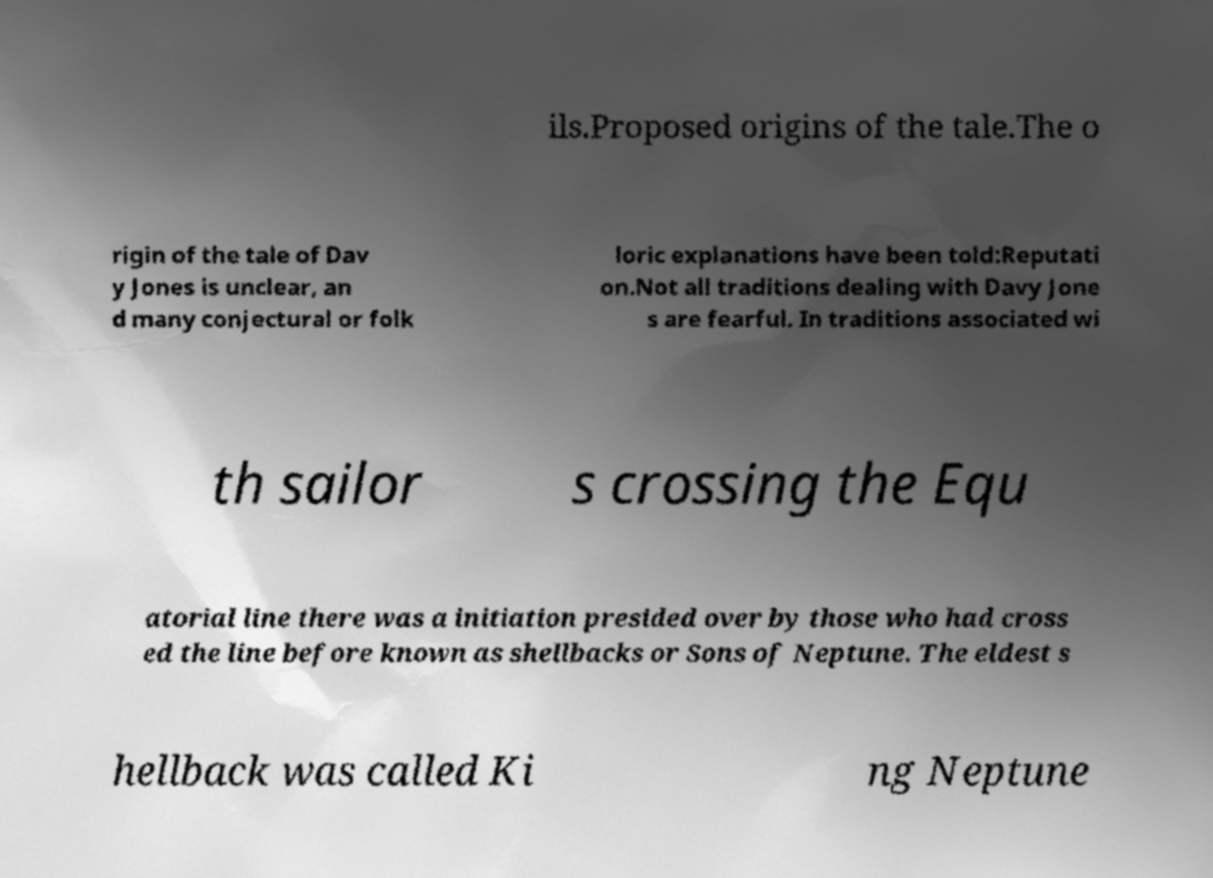Can you accurately transcribe the text from the provided image for me? ils.Proposed origins of the tale.The o rigin of the tale of Dav y Jones is unclear, an d many conjectural or folk loric explanations have been told:Reputati on.Not all traditions dealing with Davy Jone s are fearful. In traditions associated wi th sailor s crossing the Equ atorial line there was a initiation presided over by those who had cross ed the line before known as shellbacks or Sons of Neptune. The eldest s hellback was called Ki ng Neptune 